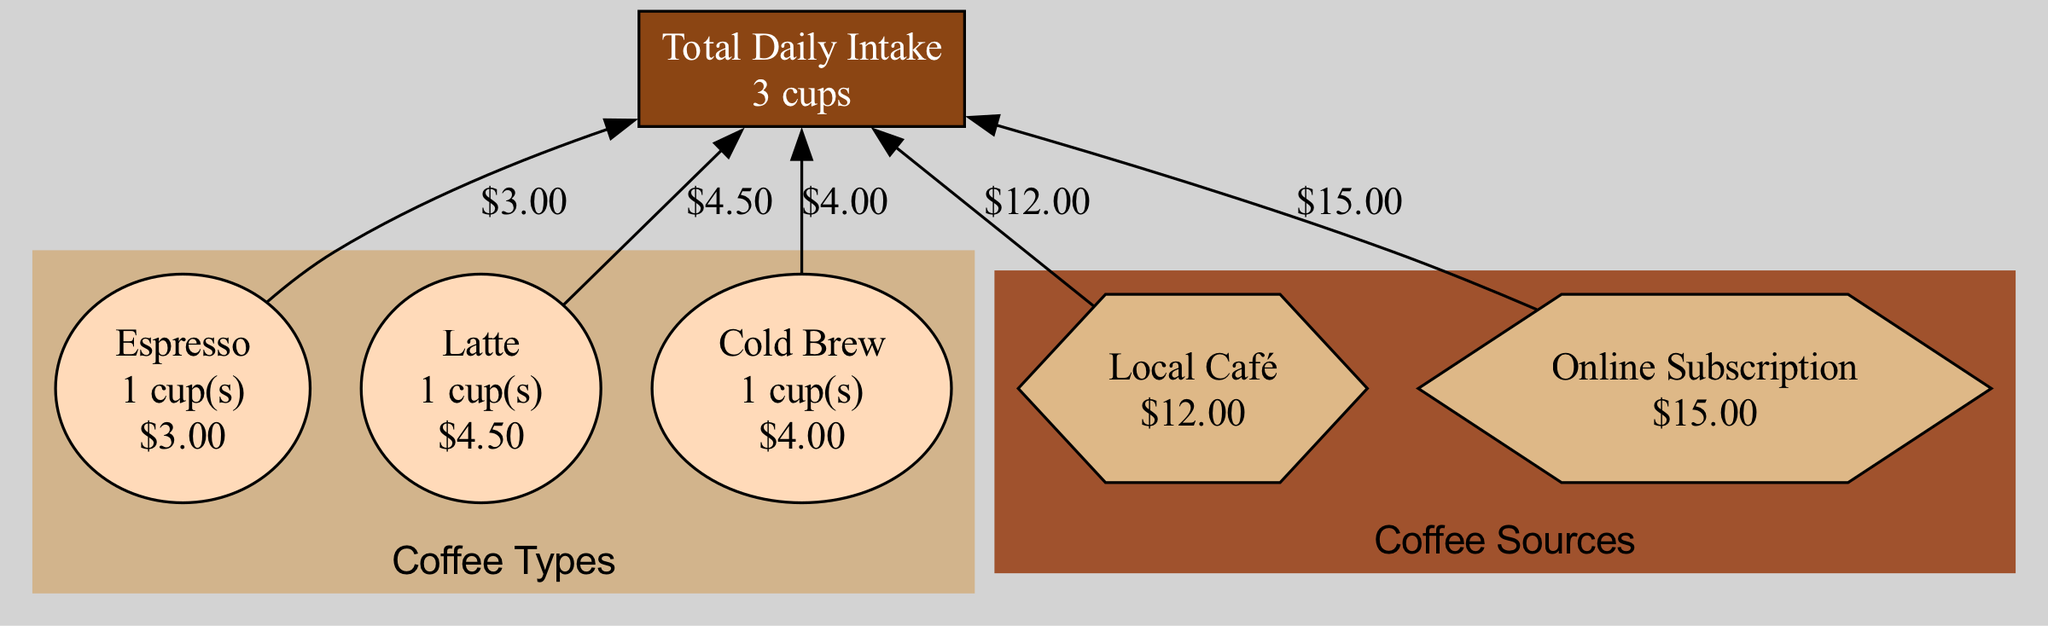What is the total number of cups consumed daily? The diagram shows a node labeled "Total Daily Intake" which indicates the total number of cups consumed daily. It states "3 cups", therefore, the answer is derived directly from this node.
Answer: 3 cups How much was spent at the Local Café? The diagram includes a source node labeled "Local Café" with a cost description of "$12.00". The answer comes from the information directly presented within this node.
Answer: $12.00 What type of coffee was consumed the most? In the diagram, each coffee type is represented as a node along with the amount consumed. The types listed are Espresso, Latte, and Cold Brew; each has 1 cup noted next to it, thus no type is consumed more than the others as per the amount specified.
Answer: None What is the total cost of coffee consumption? The total cost can be calculated by adding the individual costs from the coffee types (Espresso, Latte, Cold Brew) and the sources (Local Café, Online Subscription). The coffee costs add up to $11.50, and the sources total $27.00, resulting in a final total cost of $38.50.
Answer: $38.50 Which coffee type has the highest individual cost? Comparing the costs of the coffee types displayed in their respective nodes, Espresso is $3.00, Latte is $4.50, and Cold Brew is $4.00. Among these, Latte has the highest individual cost.
Answer: Latte What is the total spent on online subscriptions? The node labeled "Online Subscription" indicates that the total spent is "$15.00". This figure is explicitly mentioned within the node, providing a direct answer.
Answer: $15.00 How many edges are coming from the Latte node? The diagram illustrates each coffee type node connected to the total cup consumption with an edge. Since each coffee type only connects to the "Total" node, there is only one edge coming from the Latte node.
Answer: 1 edge Which source contributed the most to total spending? The nodes for the sources list "Local Café" at $12.00 and "Online Subscription" at $15.00. Since $15.00 is higher than $12.00, the Online Subscription contributed the most to total spending.
Answer: Online Subscription What color is used to represent coffee types in the diagram? Each coffee type is encapsulated in a subgraph highlighted with a specific color identified within the diagram. The color for the coffee types subgraph is "#D2B48C".
Answer: #D2B48C 